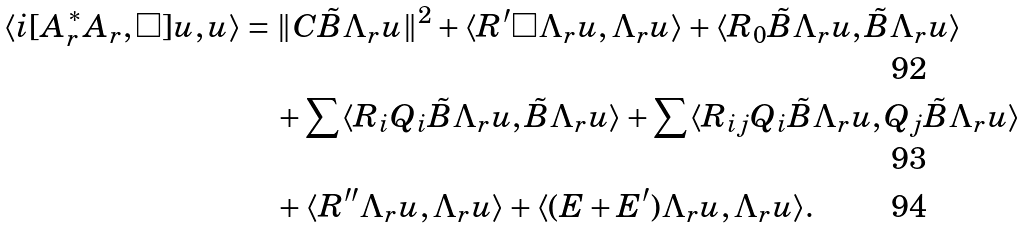Convert formula to latex. <formula><loc_0><loc_0><loc_500><loc_500>\langle i [ A _ { r } ^ { * } A _ { r } , \Box ] u , u \rangle & = \| C \tilde { B } \Lambda _ { r } u \| ^ { 2 } + \langle R ^ { \prime } \Box \Lambda _ { r } u , \Lambda _ { r } u \rangle + \langle R _ { 0 } \tilde { B } \Lambda _ { r } u , \tilde { B } \Lambda _ { r } u \rangle \\ & \quad + \sum \langle R _ { i } Q _ { i } \tilde { B } \Lambda _ { r } u , \tilde { B } \Lambda _ { r } u \rangle + \sum \langle R _ { i j } Q _ { i } \tilde { B } \Lambda _ { r } u , Q _ { j } \tilde { B } \Lambda _ { r } u \rangle \\ & \quad + \langle R ^ { \prime \prime } \Lambda _ { r } u , \Lambda _ { r } u \rangle + \langle ( E + E ^ { \prime } ) \Lambda _ { r } u , \Lambda _ { r } u \rangle .</formula> 